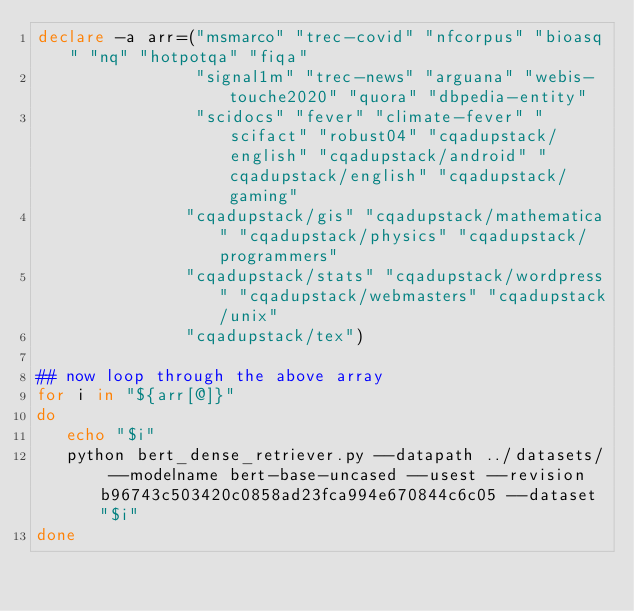Convert code to text. <code><loc_0><loc_0><loc_500><loc_500><_Bash_>declare -a arr=("msmarco" "trec-covid" "nfcorpus" "bioasq" "nq" "hotpotqa" "fiqa"
                "signal1m" "trec-news" "arguana" "webis-touche2020" "quora" "dbpedia-entity"
                "scidocs" "fever" "climate-fever" "scifact" "robust04" "cqadupstack/english" "cqadupstack/android" "cqadupstack/english" "cqadupstack/gaming"
               "cqadupstack/gis" "cqadupstack/mathematica" "cqadupstack/physics" "cqadupstack/programmers"
               "cqadupstack/stats" "cqadupstack/wordpress" "cqadupstack/webmasters" "cqadupstack/unix"
               "cqadupstack/tex")

## now loop through the above array
for i in "${arr[@]}"
do
   echo "$i"
   python bert_dense_retriever.py --datapath ../datasets/ --modelname bert-base-uncased --usest --revision b96743c503420c0858ad23fca994e670844c6c05 --dataset "$i"
done
</code> 